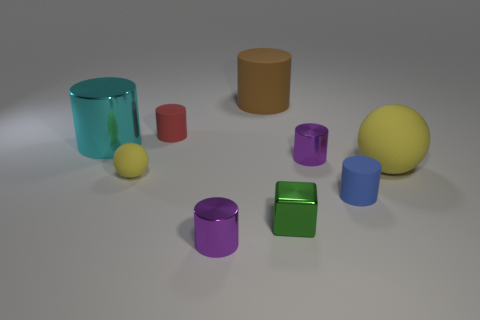What number of matte things are small yellow objects or spheres?
Provide a succinct answer. 2. What color is the tiny matte object that is to the right of the brown rubber cylinder?
Ensure brevity in your answer.  Blue. What shape is the red thing that is the same size as the cube?
Offer a terse response. Cylinder. Does the small sphere have the same color as the tiny rubber cylinder in front of the big ball?
Make the answer very short. No. How many things are tiny cylinders left of the big brown rubber object or yellow matte objects to the right of the tiny blue thing?
Provide a short and direct response. 3. What material is the ball that is the same size as the cyan object?
Offer a very short reply. Rubber. What number of other things are there of the same material as the large cyan thing
Keep it short and to the point. 3. Do the yellow rubber thing left of the blue object and the matte thing in front of the small yellow matte thing have the same shape?
Make the answer very short. No. There is a tiny metallic cylinder that is in front of the large thing to the right of the tiny purple metal thing right of the big rubber cylinder; what is its color?
Your answer should be very brief. Purple. How many other objects are there of the same color as the small sphere?
Ensure brevity in your answer.  1. 